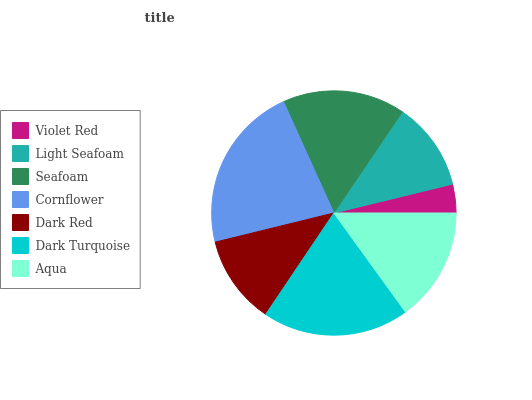Is Violet Red the minimum?
Answer yes or no. Yes. Is Cornflower the maximum?
Answer yes or no. Yes. Is Light Seafoam the minimum?
Answer yes or no. No. Is Light Seafoam the maximum?
Answer yes or no. No. Is Light Seafoam greater than Violet Red?
Answer yes or no. Yes. Is Violet Red less than Light Seafoam?
Answer yes or no. Yes. Is Violet Red greater than Light Seafoam?
Answer yes or no. No. Is Light Seafoam less than Violet Red?
Answer yes or no. No. Is Aqua the high median?
Answer yes or no. Yes. Is Aqua the low median?
Answer yes or no. Yes. Is Light Seafoam the high median?
Answer yes or no. No. Is Seafoam the low median?
Answer yes or no. No. 